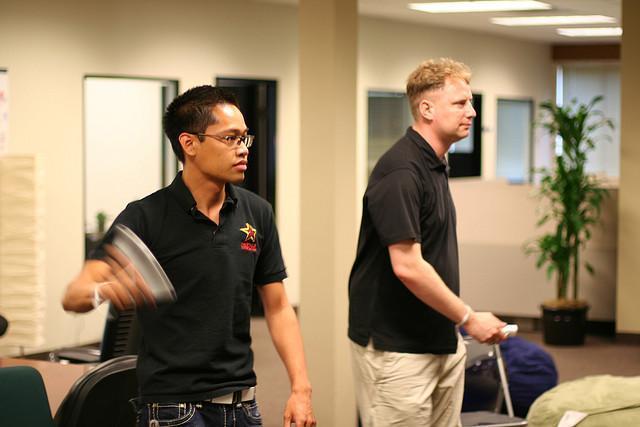How many people are in the picture?
Give a very brief answer. 2. How many chairs can you see?
Give a very brief answer. 3. How many sheep are standing on the rock?
Give a very brief answer. 0. 